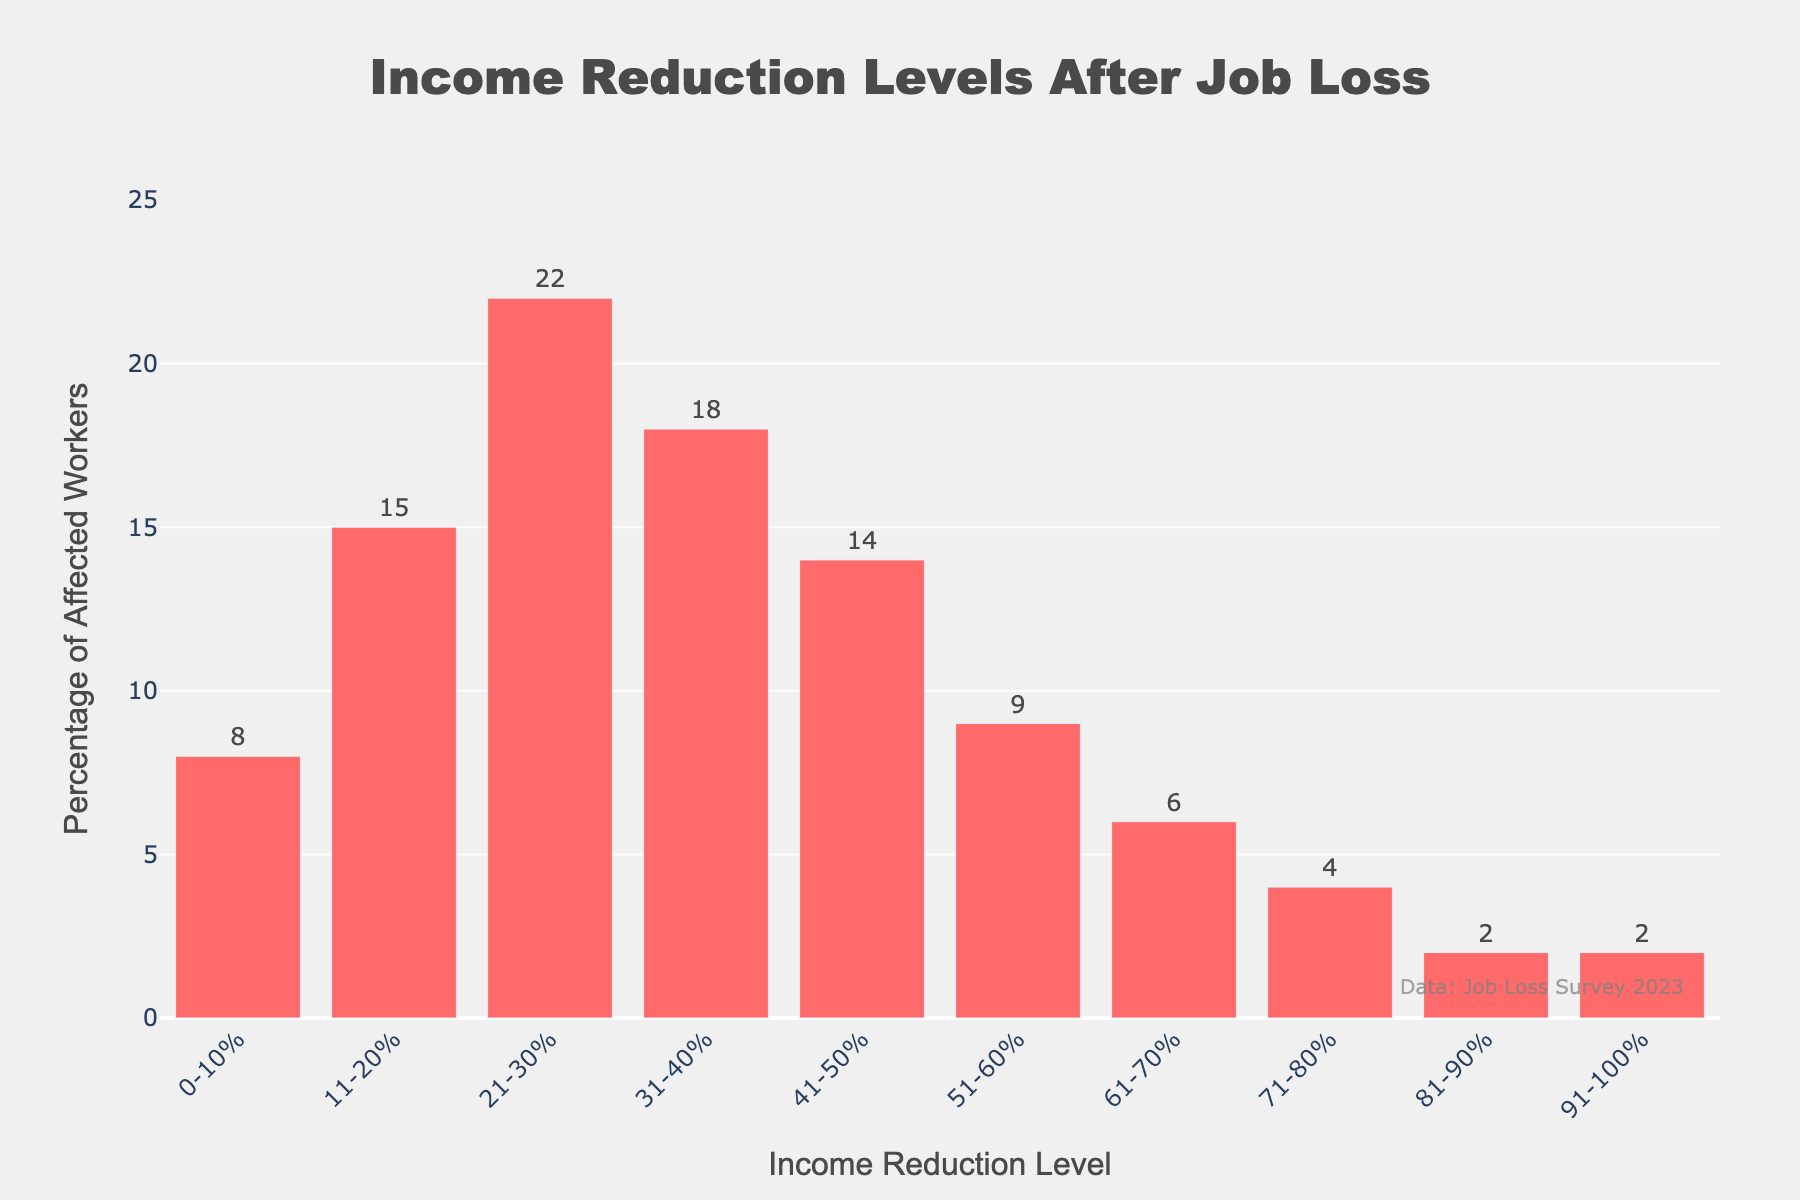Which income reduction level has the highest percentage of affected workers? First, look for the tallest bar in the chart. The tallest bar represents the 21-30% income reduction level with a height indicating 22% of affected workers.
Answer: 21-30% Which income reduction levels have the smallest percentage of affected workers? Look for the shortest bars. The bars for the 81-90% and 91-100% income reduction levels are the shortest, both standing at 2%.
Answer: 81-90% and 91-100% How many income reduction levels have more than 15% of affected workers? Identify all bars with a height greater than 15%. The 11-20%, 21-30%, and 31-40% levels have heights of 15%, 22%, and 18%, respectively. Therefore, there are three levels.
Answer: Three levels What is the total percentage of workers affected by an income reduction of 40% or less? Sum the percentages for the 0-10%, 11-20%, 21-30%, and 31-40% levels. This is 8 + 15 + 22 + 18 = 63%.
Answer: 63% Compare the percentage of workers affected in the 31-40% and 51-60% income reduction levels. Look at the heights of the two bars for these levels. The 31-40% level is at 18% while the 51-60% level is at 9%. Therefore, 31-40% has more affected workers.
Answer: 31-40% What is the difference in the percentage of affected workers between the 41-50% and 71-80% income reduction levels? Subtract the percentage of the 71-80% level (4%) from the 41-50% level (14%). 14% - 4% = 10%.
Answer: 10% What is the average percentage of affected workers for the income reduction levels 11-20%, 21-30%, and 31-40%? Sum the percentages and divide by the number of levels: (15 + 22 + 18) / 3 = 55 / 3 ≈ 18.33%.
Answer: 18.33% If you combine the percentages of workers affected in the 41-50%, 51-60%, and 61-70% income reduction levels, what is the total percentage? Sum the percentages for these levels: 14 + 9 + 6 = 29%.
Answer: 29% How does the percentage of workers affected in the 0-10% income reduction level compare to the 61-70% level? The 0-10% level has 8%, while the 61-70% level has 6%. The 0-10% level has a slightly higher percentage.
Answer: 0-10% is higher What proportion of workers experienced a reduction between 20% and 60% inclusive? Sum the percentages for the 21-30%, 31-40%, 41-50%, and 51-60% levels: 22 + 18 + 14 + 9 = 63%.
Answer: 63% 